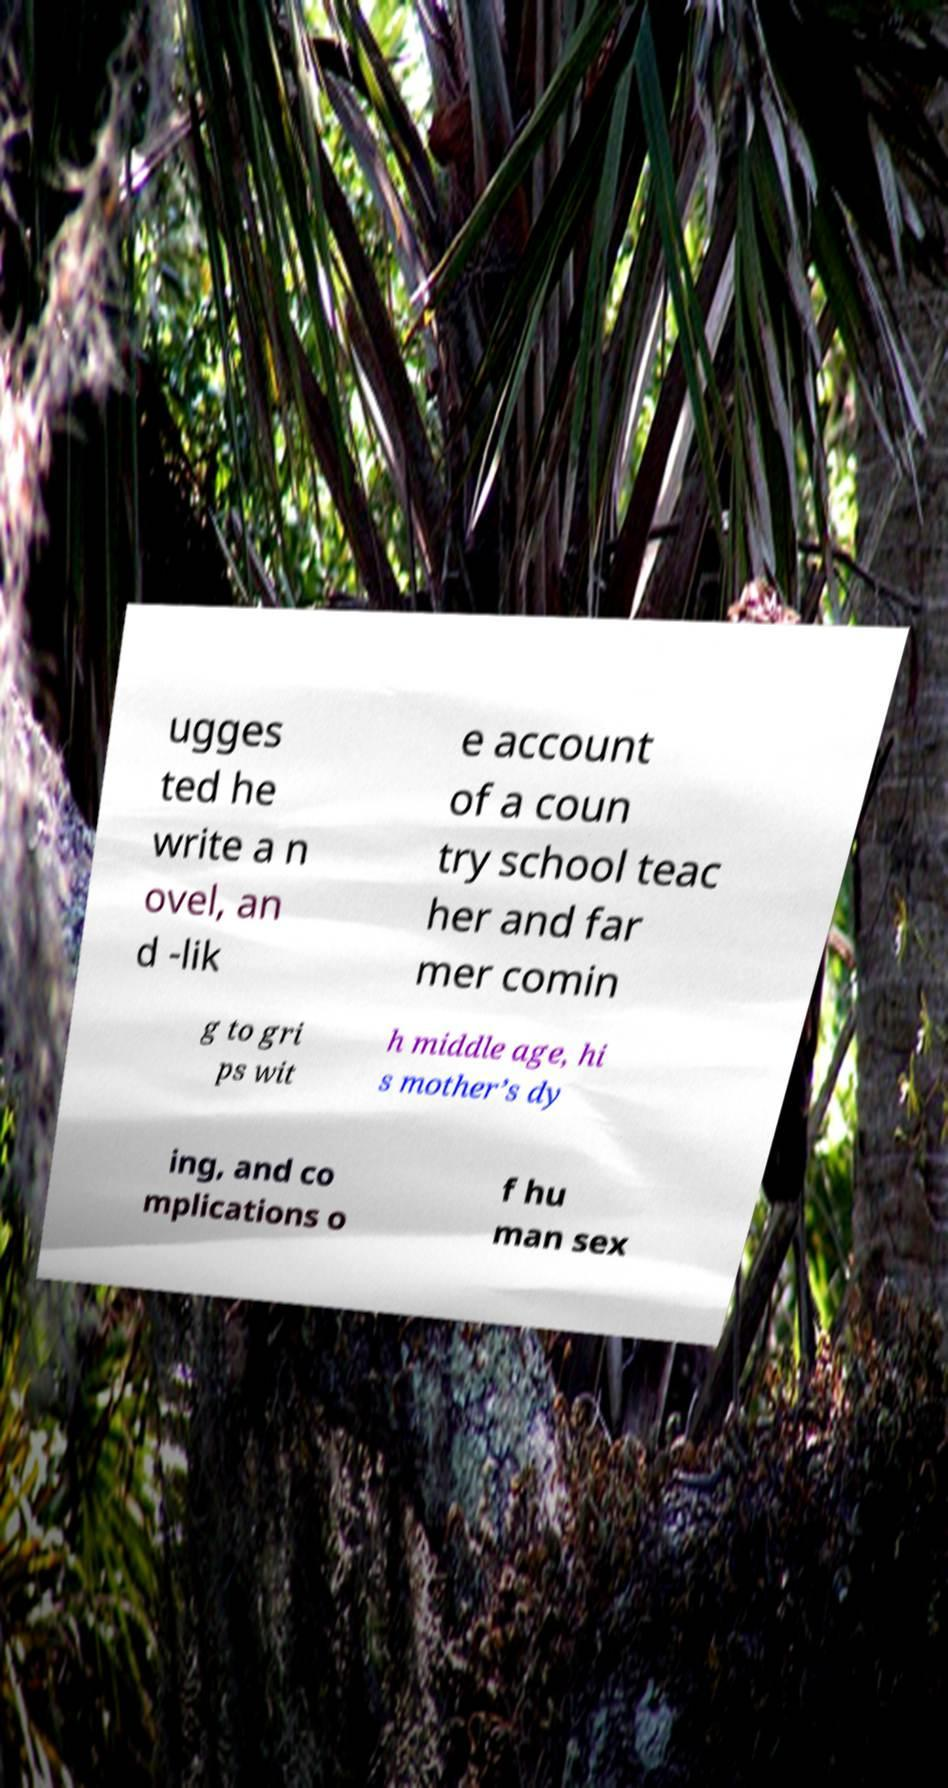Can you accurately transcribe the text from the provided image for me? ugges ted he write a n ovel, an d -lik e account of a coun try school teac her and far mer comin g to gri ps wit h middle age, hi s mother’s dy ing, and co mplications o f hu man sex 